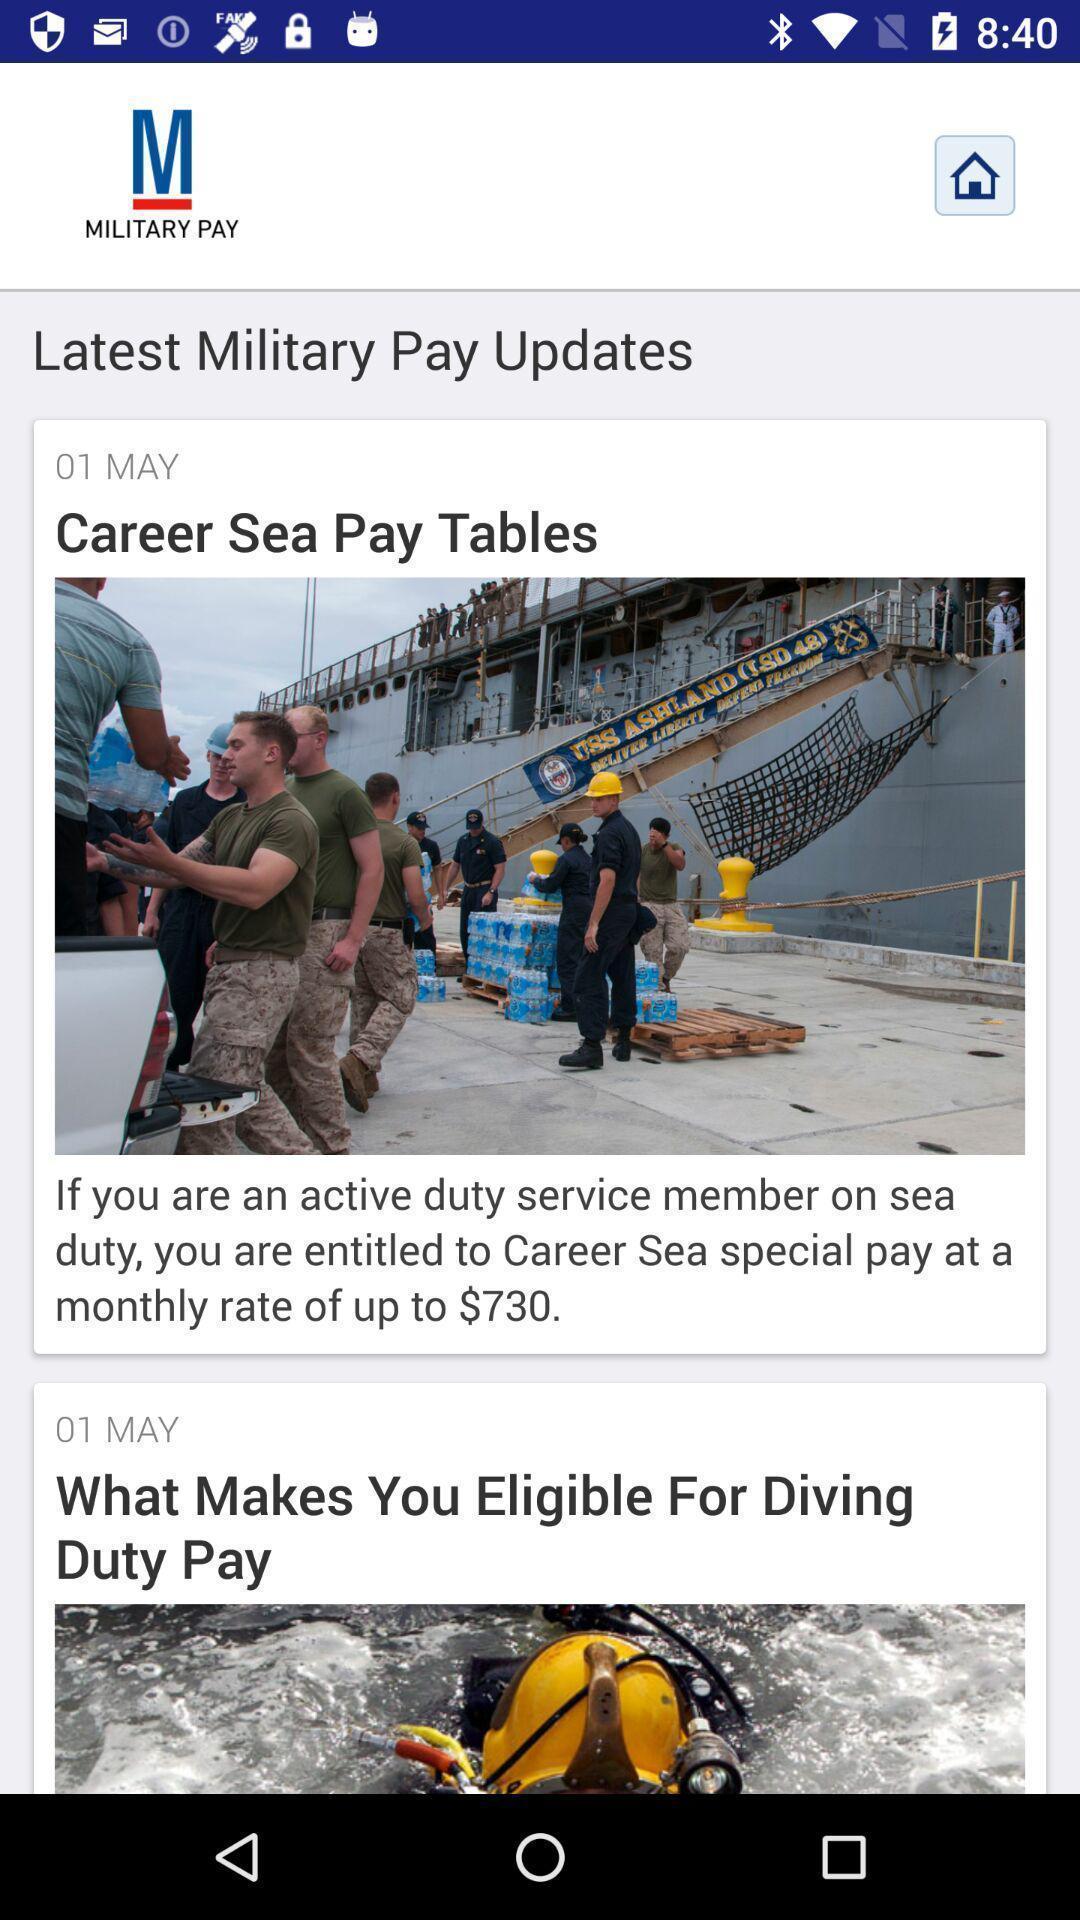Describe the key features of this screenshot. Screen shows updates. 